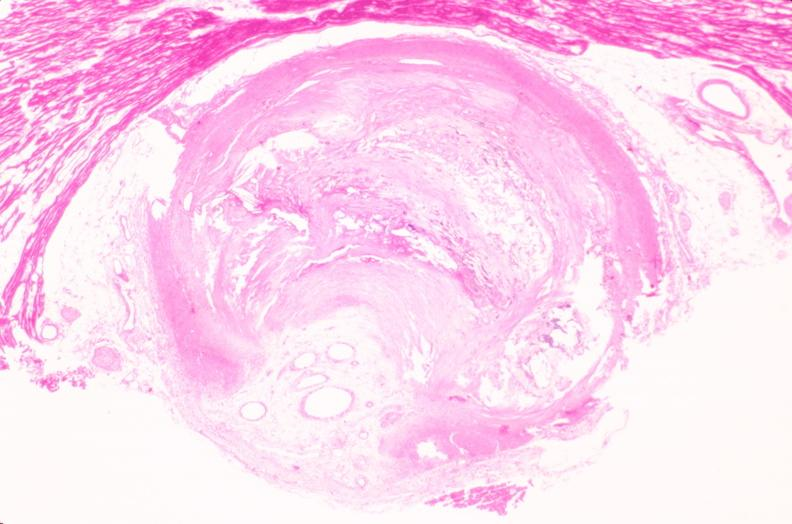s cardiovascular present?
Answer the question using a single word or phrase. Yes 